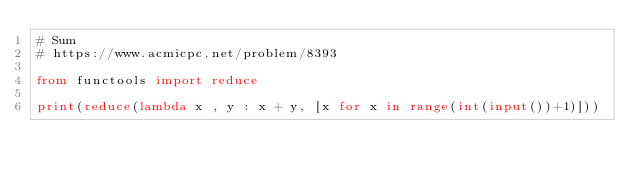<code> <loc_0><loc_0><loc_500><loc_500><_Python_># Sum
# https://www.acmicpc.net/problem/8393

from functools import reduce

print(reduce(lambda x , y : x + y, [x for x in range(int(input())+1)]))
</code> 